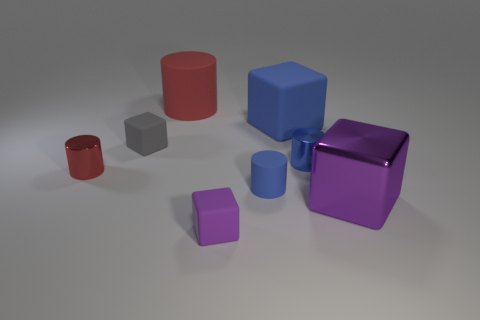Do the small matte cylinder and the big matte block have the same color?
Your answer should be very brief. Yes. What color is the block right of the blue matte object behind the tiny red cylinder that is to the left of the big red matte object?
Your response must be concise. Purple. There is a matte block that is the same size as the purple metal thing; what is its color?
Give a very brief answer. Blue. What number of matte things are either gray blocks or big red cylinders?
Make the answer very short. 2. What color is the big cylinder that is the same material as the large blue thing?
Your response must be concise. Red. What material is the red thing behind the small rubber block that is behind the blue metallic cylinder?
Your answer should be compact. Rubber. How many objects are either big objects behind the big metal thing or rubber blocks that are behind the small purple matte thing?
Ensure brevity in your answer.  3. How big is the purple thing that is right of the tiny rubber object that is right of the purple thing that is in front of the large purple shiny object?
Provide a succinct answer. Large. Is the number of red shiny objects behind the blue cube the same as the number of tiny blue cylinders?
Provide a succinct answer. No. Is there any other thing that has the same shape as the red rubber thing?
Provide a succinct answer. Yes. 